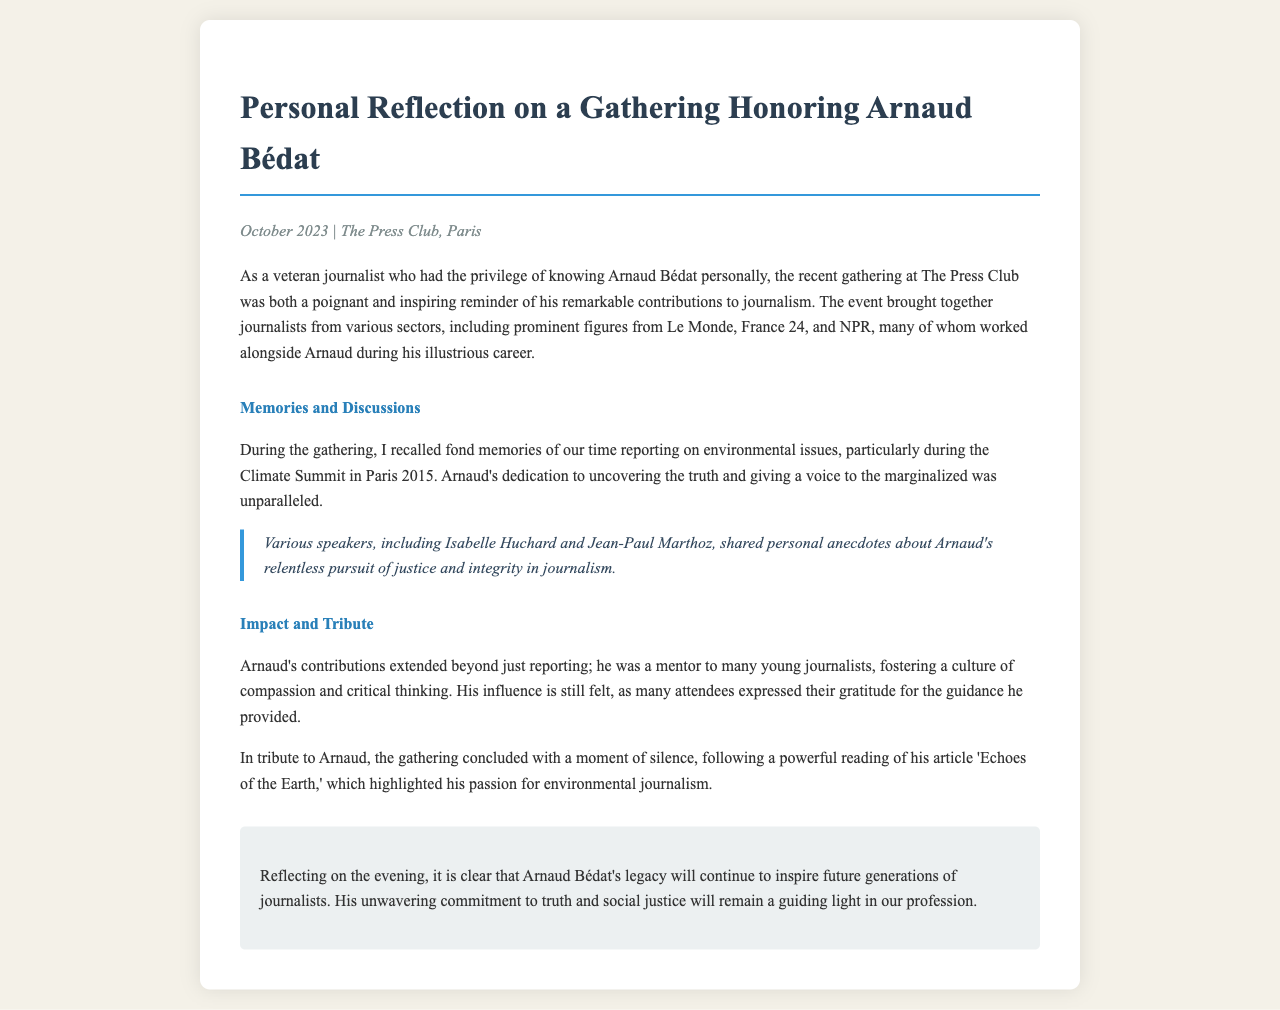What is the date of the gathering? The document states that the gathering took place in October 2023.
Answer: October 2023 Where was the gathering held? The document mentions that the gathering was at The Press Club.
Answer: The Press Club Who were some notable speakers at the gathering? The document lists Isabelle Huchard and Jean-Paul Marthoz as speakers during the event.
Answer: Isabelle Huchard and Jean-Paul Marthoz What event does the author reminisce about alongside Arnaud? The author recalls their time reporting during the Climate Summit in Paris 2015.
Answer: Climate Summit in Paris 2015 What type of journalism was Arnaud particularly passionate about? The document indicates that Arnaud had a passion for environmental journalism.
Answer: Environmental journalism What did the gathering conclude with as a tribute? It concluded with a moment of silence following a reading of Arnaud's article.
Answer: Moment of silence How was Arnaud viewed in relation to young journalists? The document states that Arnaud was a mentor to many young journalists.
Answer: Mentor What article was read during the tribute? The document specifies that 'Echoes of the Earth' was the article read.
Answer: 'Echoes of the Earth' What year did the Climate Summit take place? The document mentions the Climate Summit in Paris occurred in 2015.
Answer: 2015 